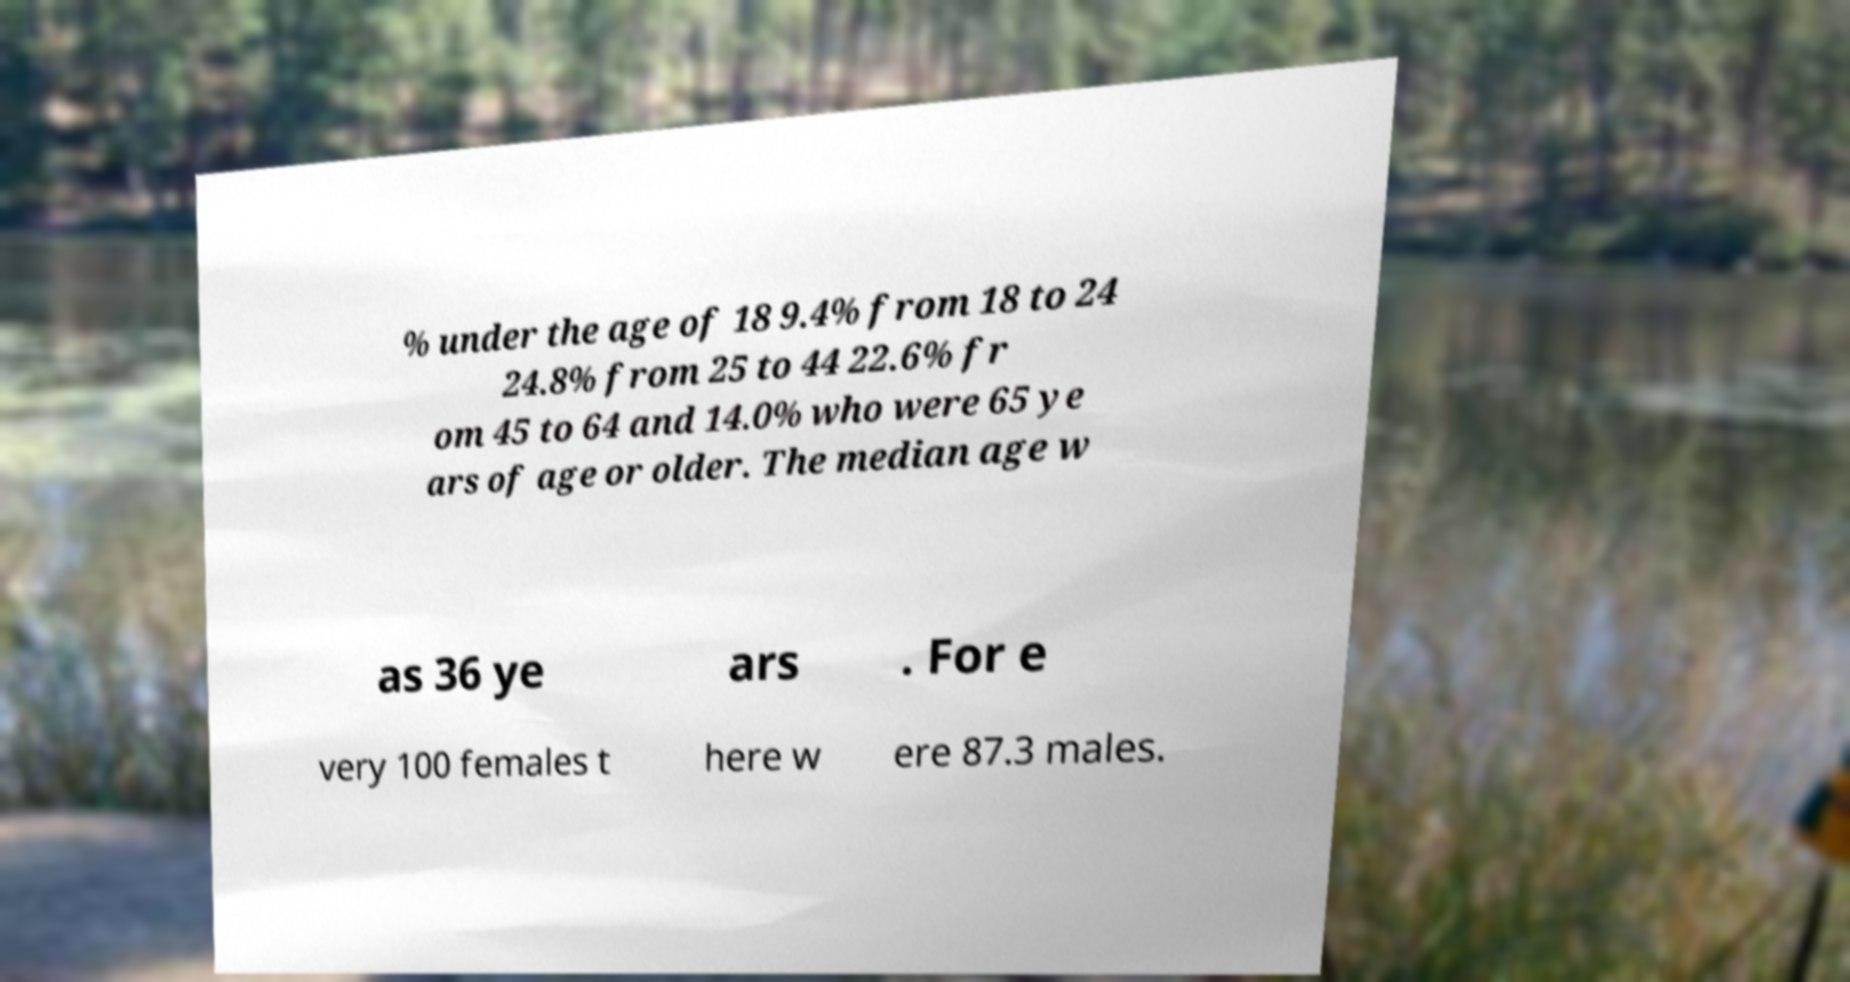For documentation purposes, I need the text within this image transcribed. Could you provide that? % under the age of 18 9.4% from 18 to 24 24.8% from 25 to 44 22.6% fr om 45 to 64 and 14.0% who were 65 ye ars of age or older. The median age w as 36 ye ars . For e very 100 females t here w ere 87.3 males. 